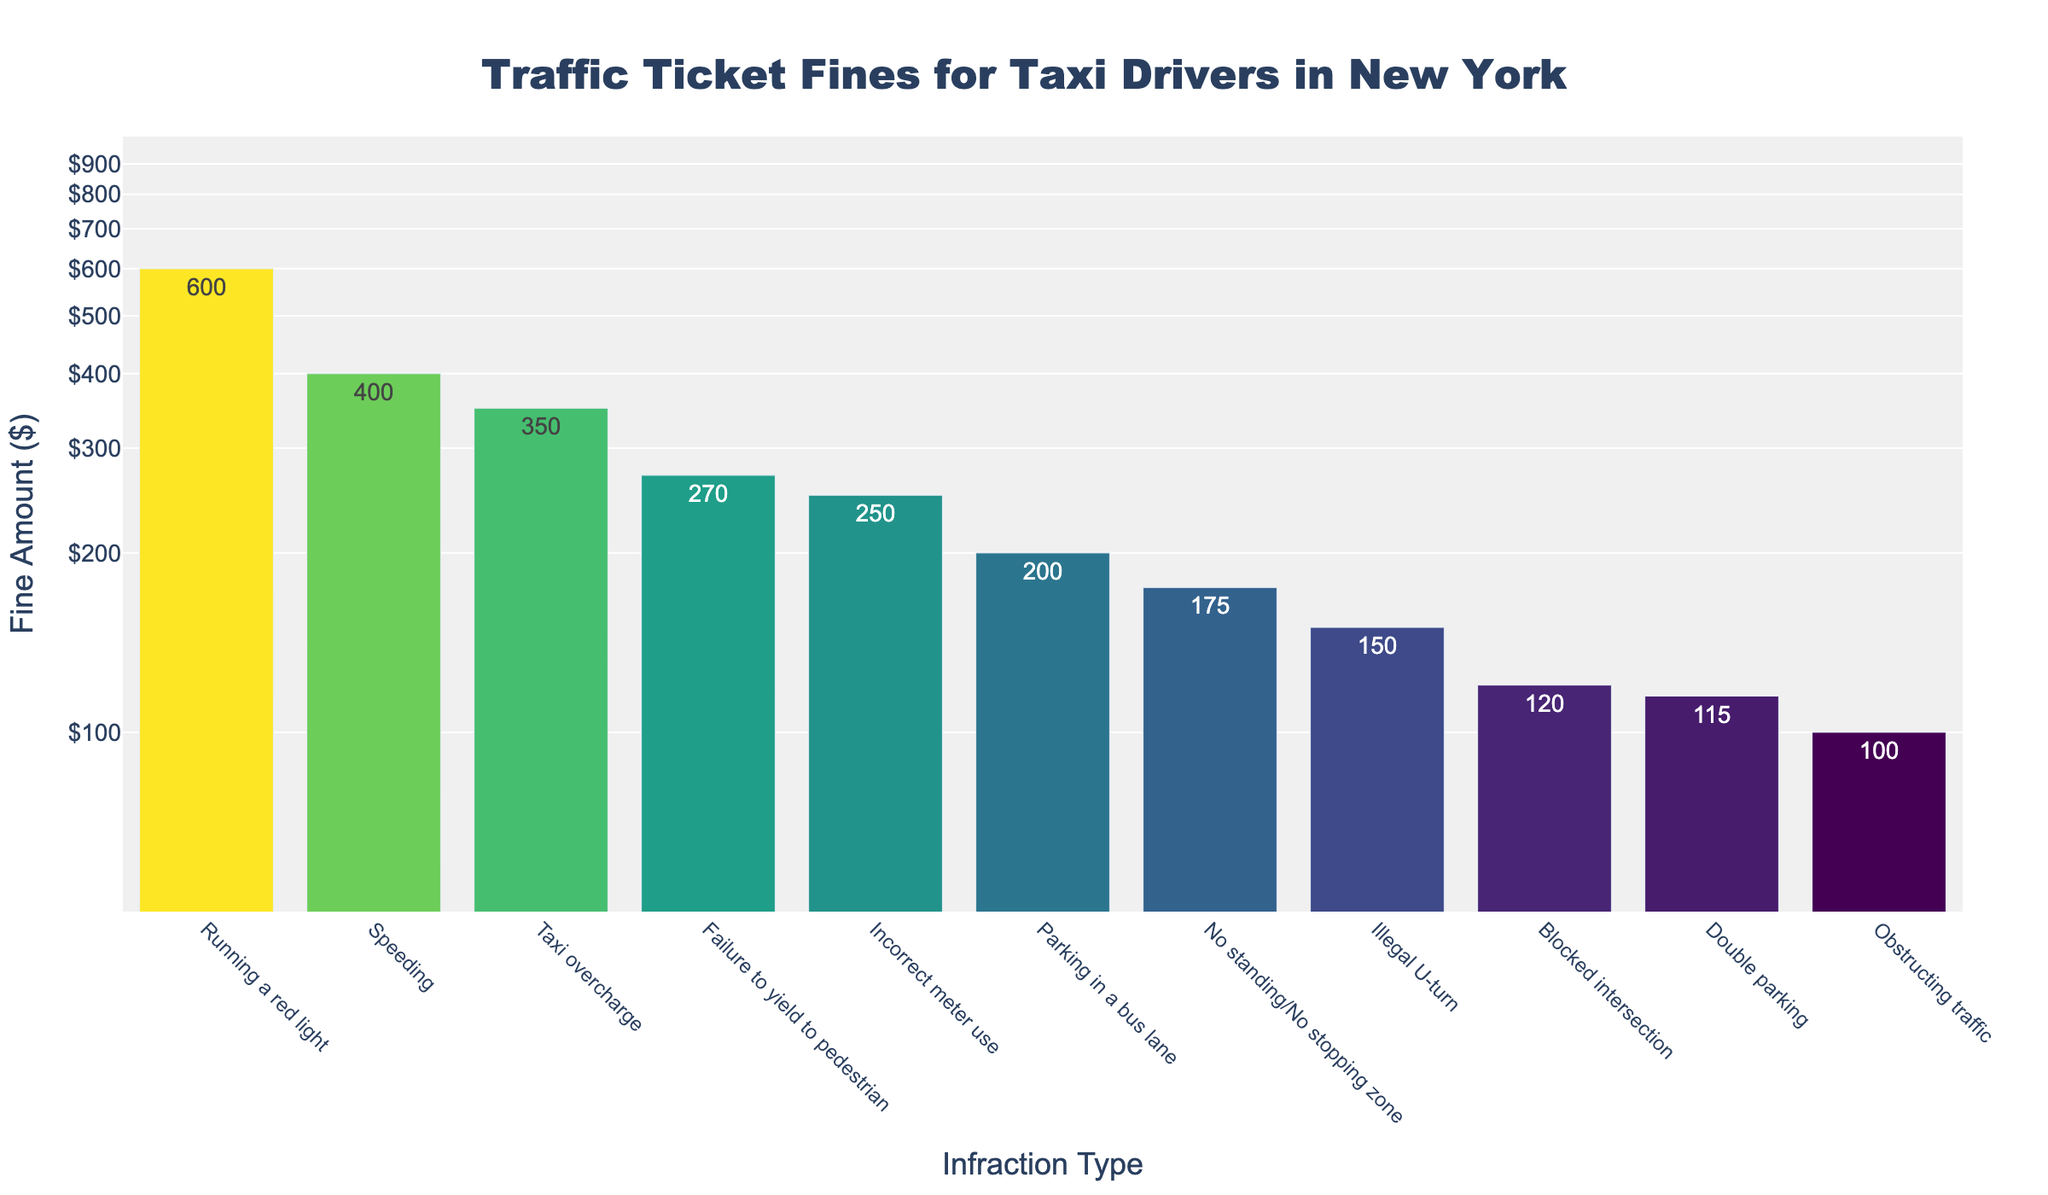What is the highest traffic ticket fine for taxi drivers? The highest fine can be identified by looking at the tallest bar in the chart. It corresponds to the "Running a red light" infraction with a fine of $600.
Answer: $600 Which infraction has the lowest fine? The lowest fine is indicated by the shortest bar in the chart, which corresponds to "Obstructing traffic" with a fine of $100.
Answer: Obstructing traffic How many infractions have fines greater than $200? Count the bars with heights corresponding to fines >$200. These infractions are: Speeding, Running a red light, Incorrect meter use, Failure to yield to pedestrian, and Taxi overcharge. There are 5 infractions in total.
Answer: 5 What is the average fine for all listed infractions? Sum up all the fines and then divide by the total number of infractions. The fines are: 400 + 150 + 600 + 200 + 115 + 250 + 120 + 175 + 270 + 100 + 350. Total = 2730. Number of infractions = 11. Average = 2730 / 11.
Answer: $248 Which fines are between $100 and $200? Identify bars with heights corresponding to fines between these values. The infractions are: Illegal U-turn ($150), Parking in a bus lane ($200), Double parking ($115), Blocked intersection ($120), and No standing/No stopping zone ($175).
Answer: Illegal U-turn, Parking in a bus lane, Double parking, Blocked intersection, No standing/No stopping zone How much more is the fine for running a red light compared to double parking? Look at the fine for "Running a red light" and "Double parking", and subtract the smaller from the larger. Running a red light = $600; Double parking = $115. Difference = 600 - 115.
Answer: $485 Rank the infractions from highest to lowest fine. List the infractions in order from the tallest to the shortest bar: Running a red light, Speeding, Taxi overcharge, Failure to yield to pedestrian, Incorrect meter use, Parking in a bus lane, No standing/No stopping zone, Illegal U-turn, Blocked intersection, Double parking, Obstructing traffic.
Answer: Running a red light, Speeding, Taxi overcharge, Failure to yield to pedestrian, Incorrect meter use, Parking in a bus lane, No standing/No stopping zone, Illegal U-turn, Blocked intersection, Double parking, Obstructing traffic What is the median fine amount? Arrange the fines in ascending order and find the middle value. Sorted fines: 100, 115, 120, 150, 175, 200, 250, 270, 350, 400, 600. The middle fine is the 6th value.
Answer: $200 Is there a fine that is four times another fine? Compare fines by checking multiples. The fine for "Running a red light" ($600) is four times the fine for "Obstructing traffic" ($100).
Answer: Yes For which infraction is the fine closest to $250? Look at the fines near $250: Double parking ($115), Incorrect meter use ($250), and No standing/No stopping zone ($175). The closest fine is for "Incorrect meter use".
Answer: Incorrect meter use 